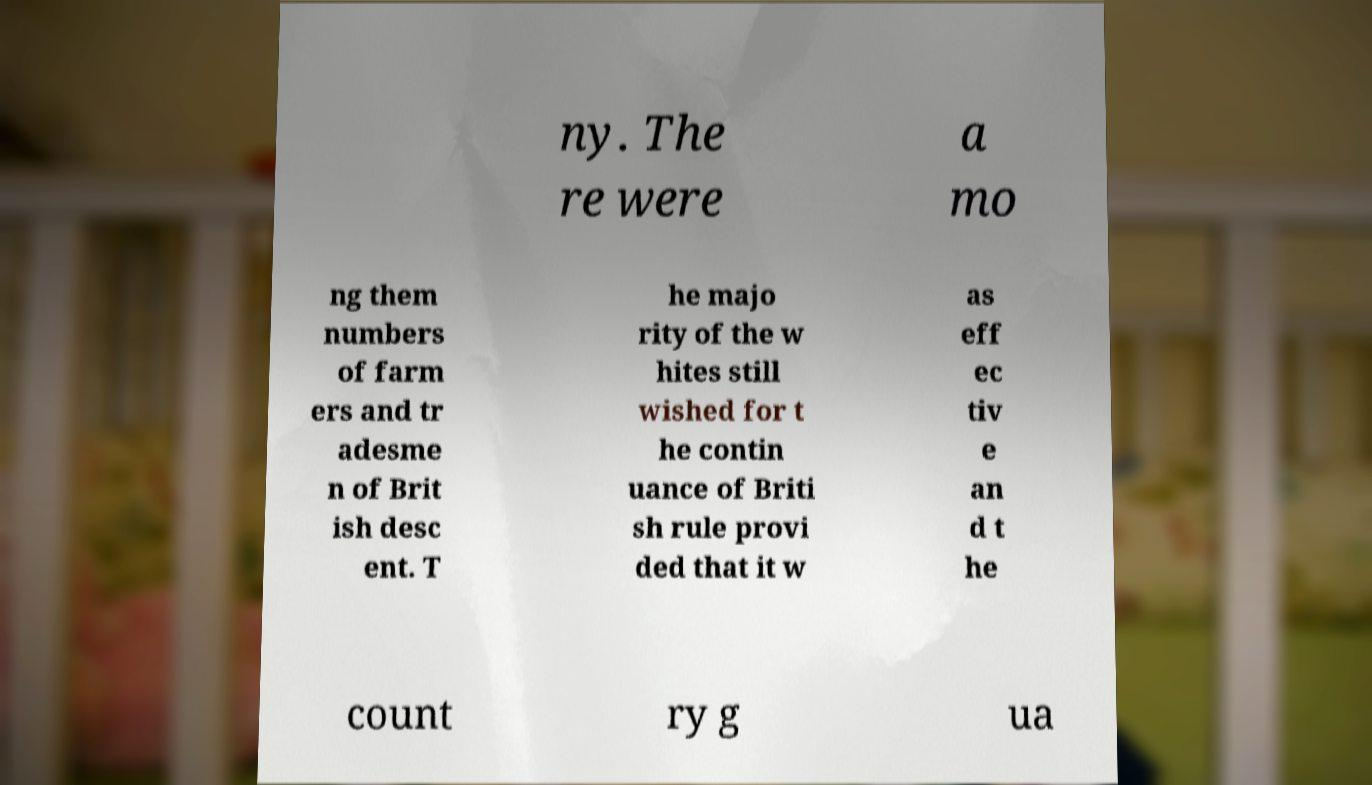Could you assist in decoding the text presented in this image and type it out clearly? ny. The re were a mo ng them numbers of farm ers and tr adesme n of Brit ish desc ent. T he majo rity of the w hites still wished for t he contin uance of Briti sh rule provi ded that it w as eff ec tiv e an d t he count ry g ua 